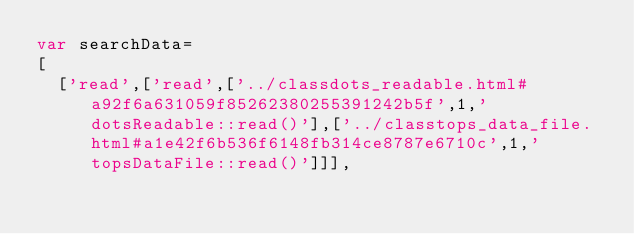<code> <loc_0><loc_0><loc_500><loc_500><_JavaScript_>var searchData=
[
  ['read',['read',['../classdots_readable.html#a92f6a631059f85262380255391242b5f',1,'dotsReadable::read()'],['../classtops_data_file.html#a1e42f6b536f6148fb314ce8787e6710c',1,'topsDataFile::read()']]],</code> 